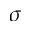<formula> <loc_0><loc_0><loc_500><loc_500>\sigma</formula> 